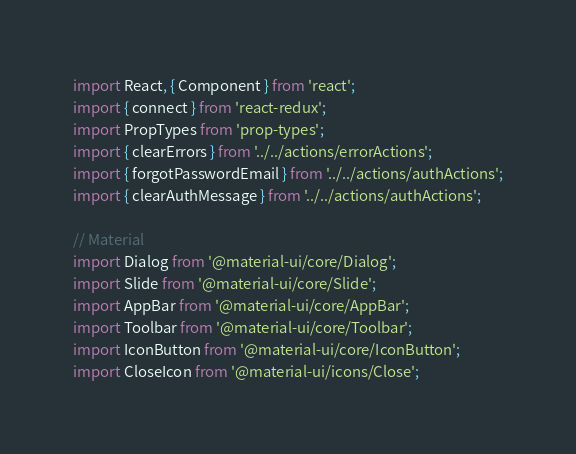<code> <loc_0><loc_0><loc_500><loc_500><_JavaScript_>import React, { Component } from 'react';
import { connect } from 'react-redux';
import PropTypes from 'prop-types';
import { clearErrors } from '../../actions/errorActions';
import { forgotPasswordEmail } from '../../actions/authActions';
import { clearAuthMessage } from '../../actions/authActions';

// Material
import Dialog from '@material-ui/core/Dialog';
import Slide from '@material-ui/core/Slide';
import AppBar from '@material-ui/core/AppBar';
import Toolbar from '@material-ui/core/Toolbar';
import IconButton from '@material-ui/core/IconButton';
import CloseIcon from '@material-ui/icons/Close';</code> 